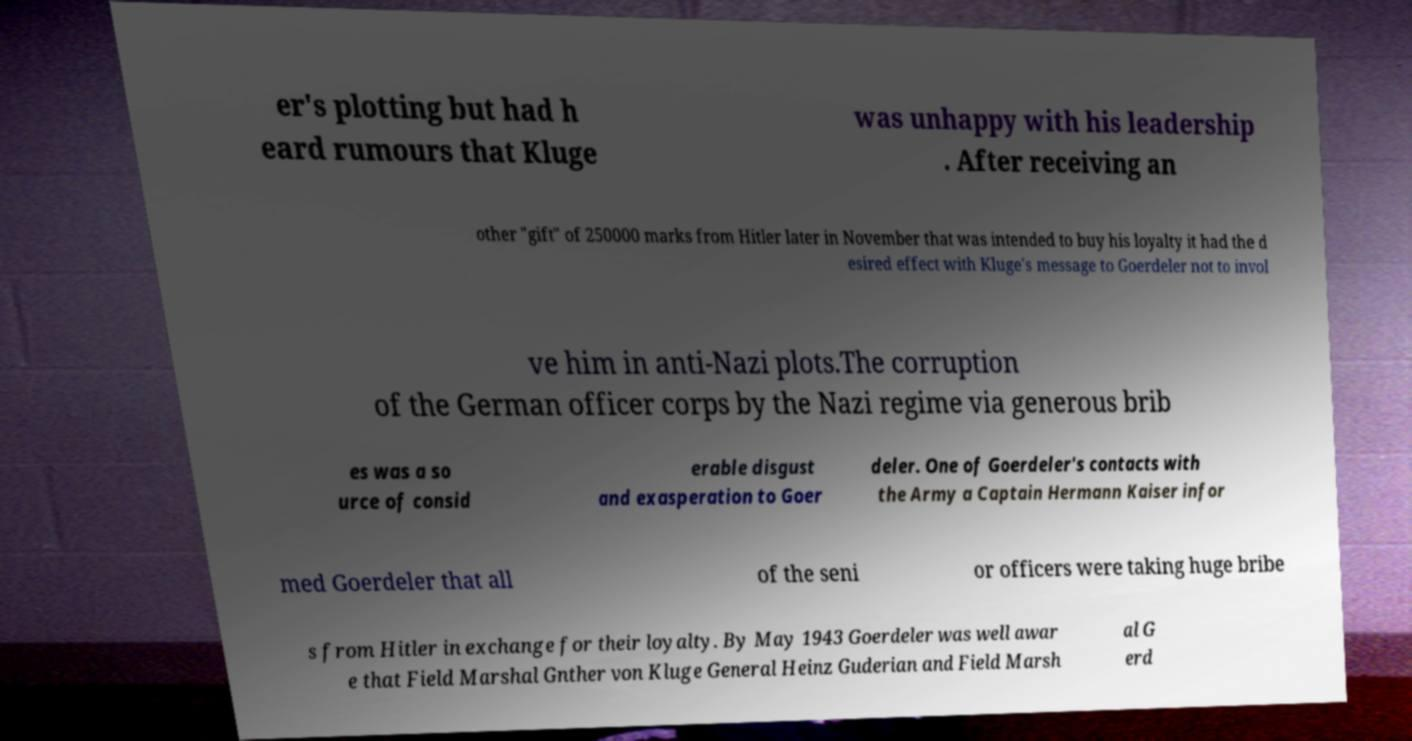Can you accurately transcribe the text from the provided image for me? er's plotting but had h eard rumours that Kluge was unhappy with his leadership . After receiving an other "gift" of 250000 marks from Hitler later in November that was intended to buy his loyalty it had the d esired effect with Kluge's message to Goerdeler not to invol ve him in anti-Nazi plots.The corruption of the German officer corps by the Nazi regime via generous brib es was a so urce of consid erable disgust and exasperation to Goer deler. One of Goerdeler's contacts with the Army a Captain Hermann Kaiser infor med Goerdeler that all of the seni or officers were taking huge bribe s from Hitler in exchange for their loyalty. By May 1943 Goerdeler was well awar e that Field Marshal Gnther von Kluge General Heinz Guderian and Field Marsh al G erd 